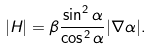<formula> <loc_0><loc_0><loc_500><loc_500>| H | = \beta \frac { \sin ^ { 2 } \alpha } { \cos ^ { 2 } \alpha } | \nabla \alpha | .</formula> 